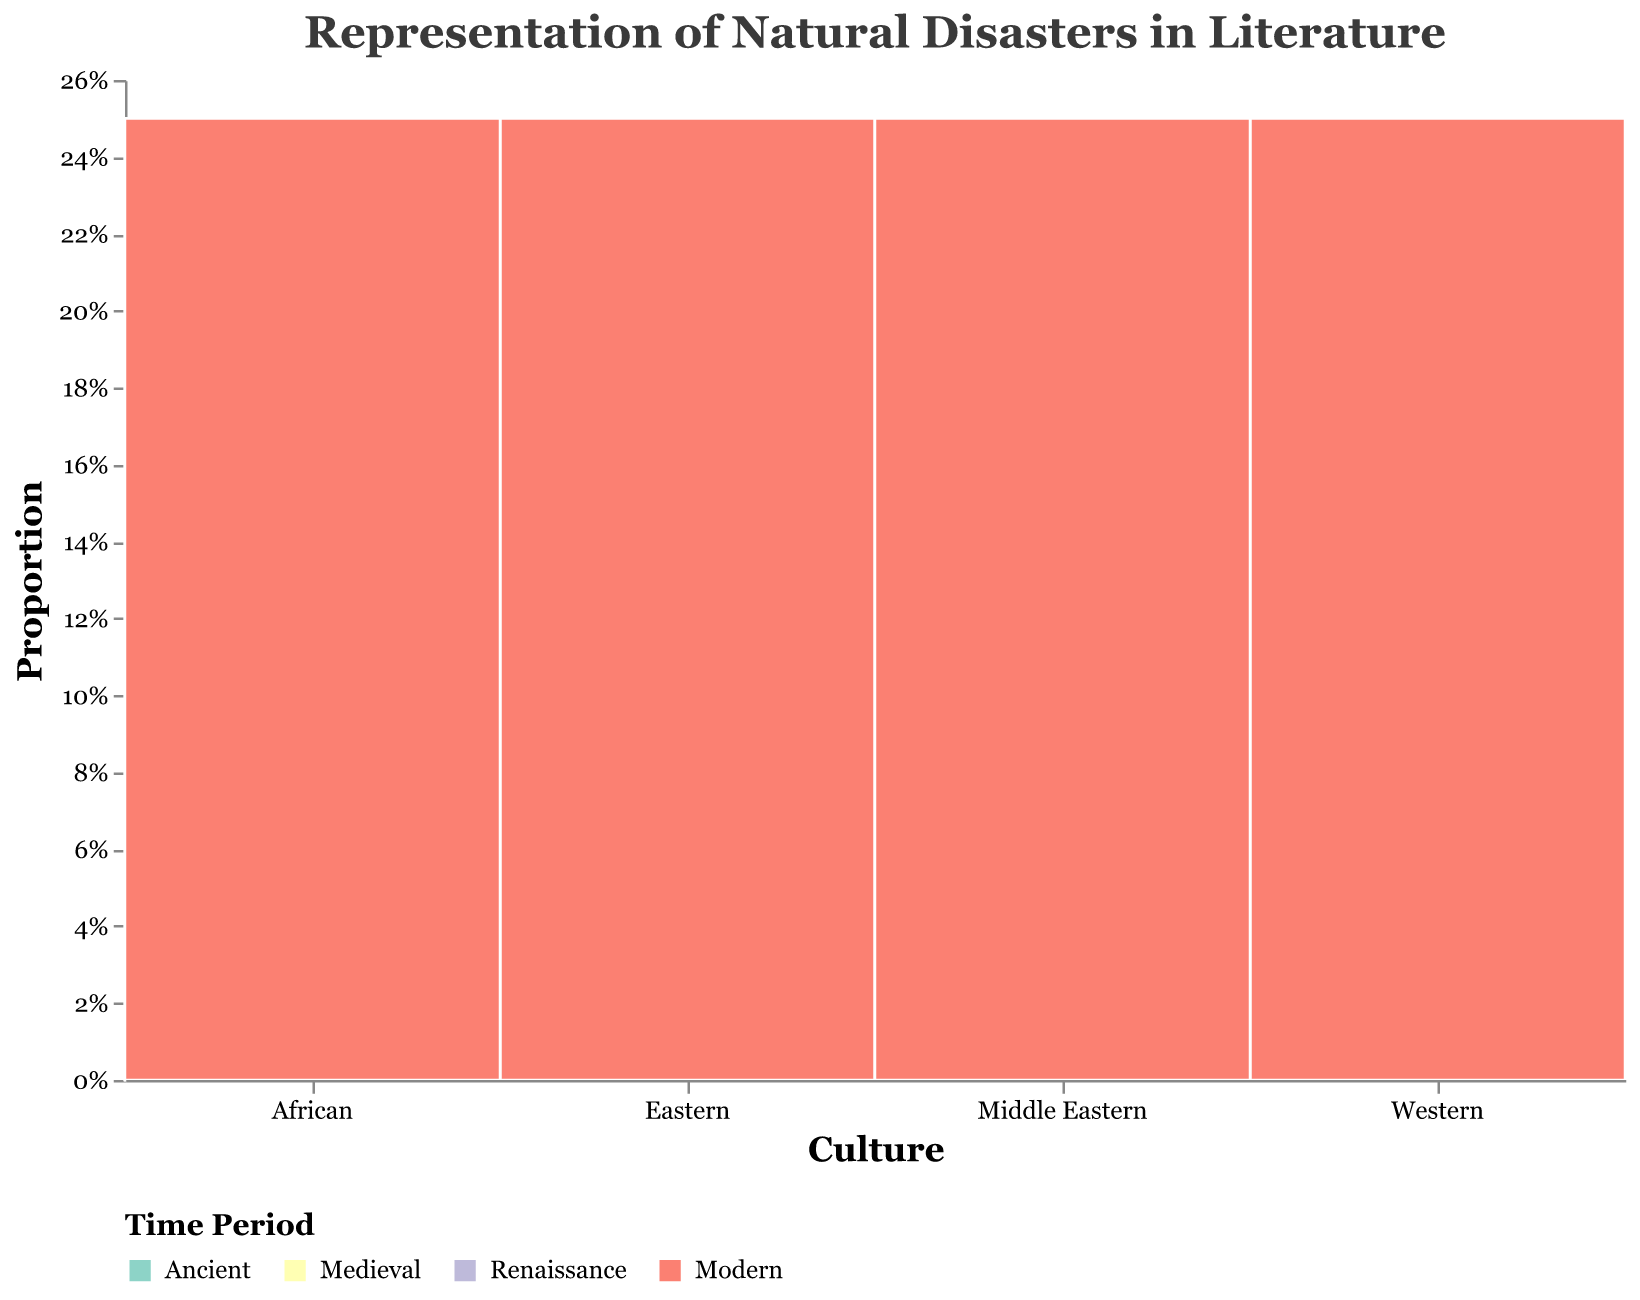What is the most represented disaster type in Western ancient literature? Observing the "Western" category and "Ancient" time period, the disaster "Flood" is represented. The number of representations for Flood is 12, which is the only entry under Western Ancient.
Answer: Flood Which time period in Eastern literature has the lowest representation of natural disasters? Examining the "Eastern" culture category, the "Medieval" period shows the lowest representation with "Volcanic Eruption" being represented 7 times.
Answer: Medieval How does the representation of disasters in Middle Eastern Medieval literature compare to Middle Eastern Renaissance literature? Comparing the "Middle Eastern" culture category, the "Medieval" period shows a representation of 13 (Drought), while the "Renaissance" period shows a representation of 7 (Earthquake). Therefore, the Medieval period has a higher representation by 6 counts.
Answer: Middle Eastern Medieval literature has a higher representation by 6 counts What proportion of disasters in African Renaissance literature is represented compared to the total African literature? In the "African" culture, the Renaissance period shows a representation of 5 (Wildfire) out of the total 30 representations across all periods. To find the proportion: 5/30 = 1/6, which is approximately 0.17 or 17%.
Answer: 17% What time period has the highest representation count of disasters for Western culture? Looking at the "Western" culture, the "Medieval" period has the highest representation with a count of 18 for Plague.
Answer: Medieval Which disaster type is most frequently represented in modern Eastern literature? Under the "Eastern" culture and "Modern" period, "Typhoon" is represented with a count of 14, which is the most frequent.
Answer: Typhoon Does African ancient literature have more representations of natural disasters than Middle Eastern ancient literature? Comparing the counts in the "Ancient" period, African literature has 11 (Famine) and Middle Eastern literature has 9 (Sandstorm). Since 11 > 9, African ancient literature has more representations.
Answer: Yes What is the total representation count for modern literature across all cultures? Adding the "Modern" period counts across all cultures: Western (15 for Hurricane), Eastern (14 for Typhoon), African (8 for Cyclone), and Middle Eastern (11 for Flood). Summing these: 15 + 14 + 8 + 11 = 48.
Answer: 48 Between African and Eastern literature, which has a higher total representation count? Summing the representation counts for "African" literature: 11 + 6 + 5 + 8 = 30. Summing for "Eastern" literature: 10 + 7 + 9 + 14 = 40. Comparing the totals, Eastern literature has a higher representation count.
Answer: Eastern How does the representation count of hurricanes in Western modern literature compare to cyclones in African modern literature? In the "Modern" period, Western literature shows a representation of 15 for hurricanes, and African literature shows a representation of 8 for cyclones. Thus, hurricanes are represented almost twice as often as cyclones in these categories.
Answer: Western hurricanes are represented almost twice as much as African cyclones 